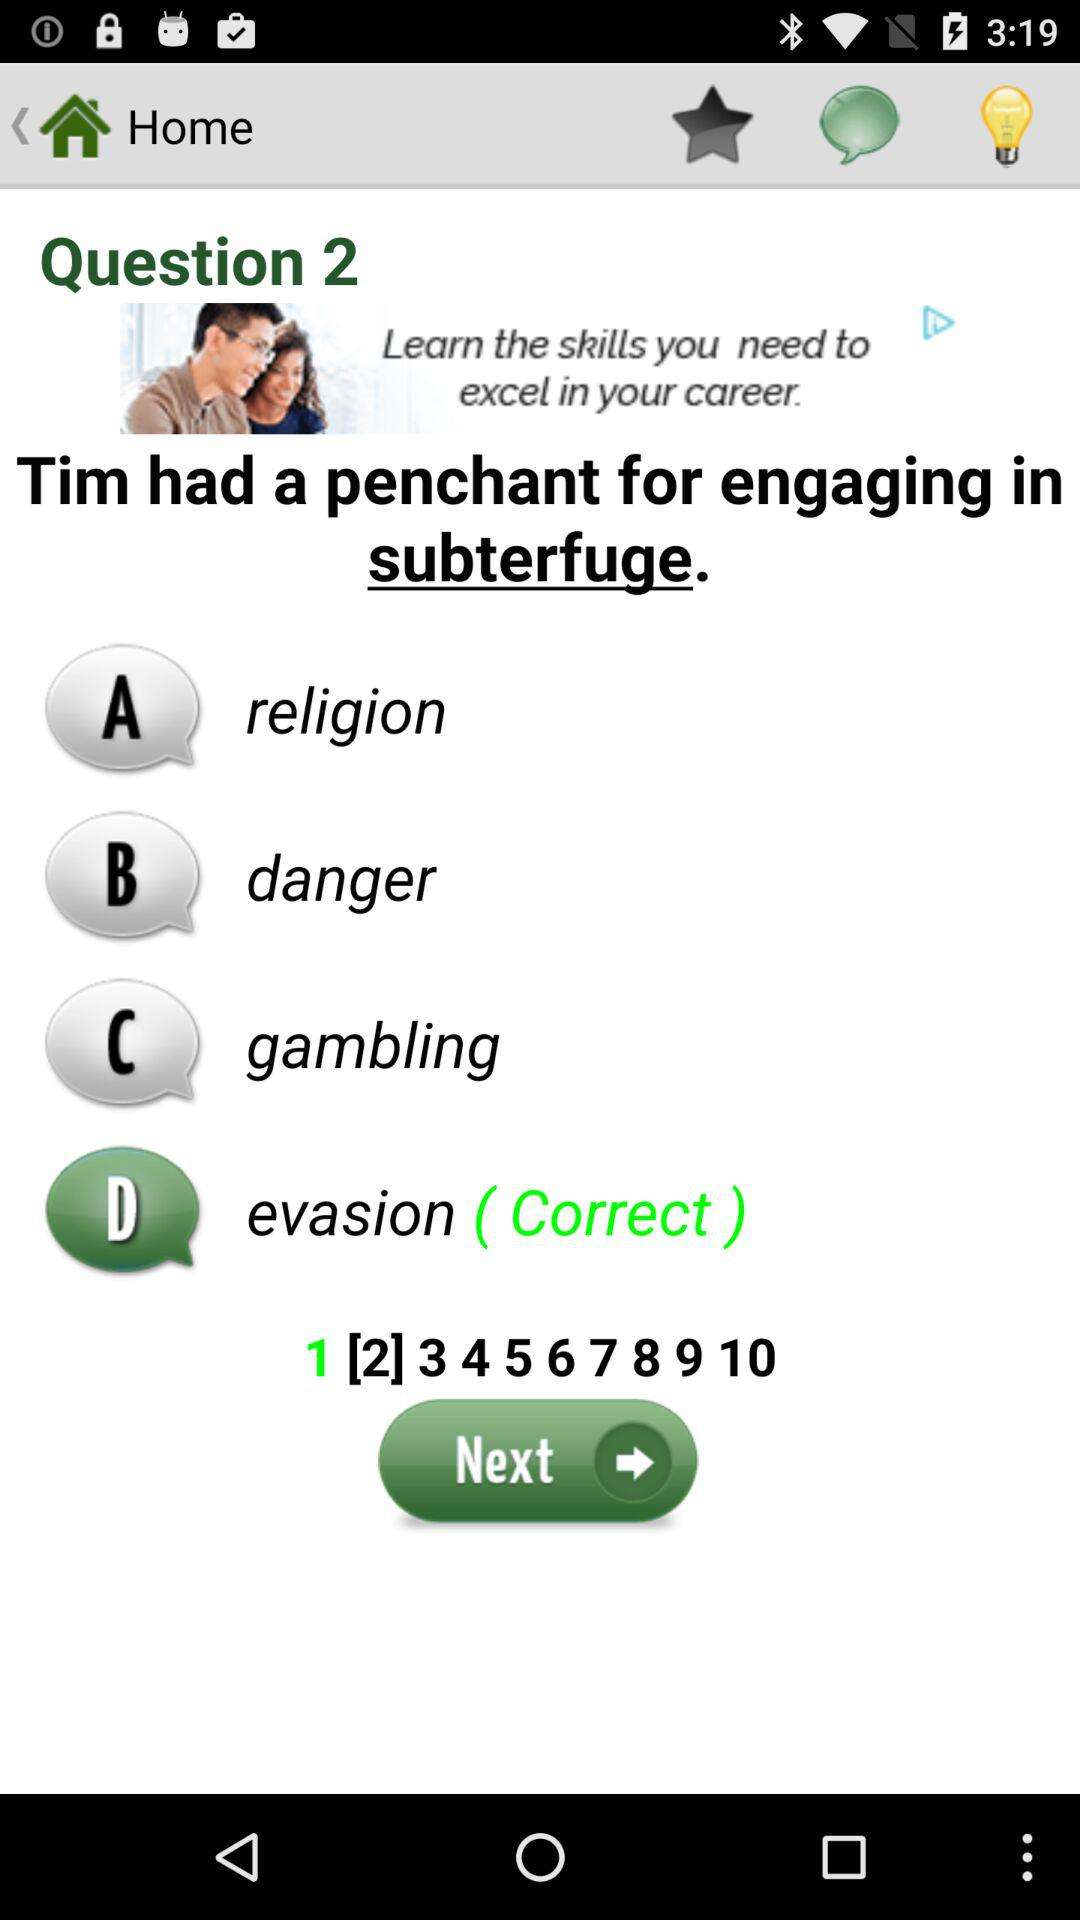How many questions in total are there? There are 10 questions in total. 